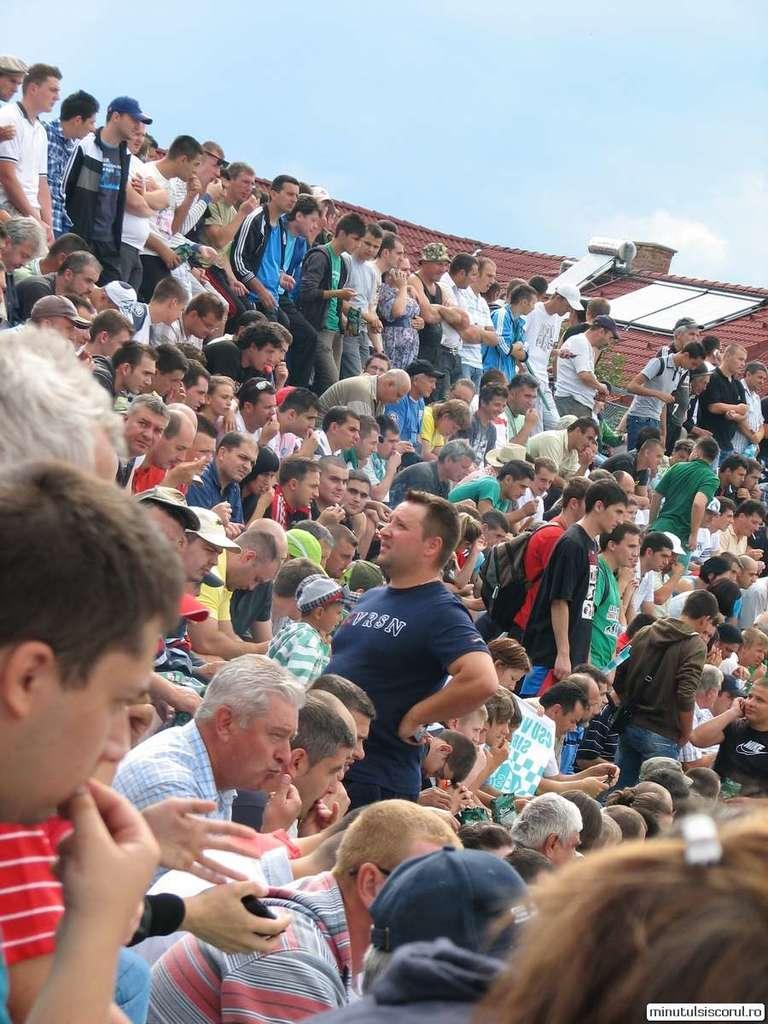Describe this image in one or two sentences. In this picture we can see some people standing here, there are some people sitting here, we can see roof top here, there is the sky at the top of the picture. 